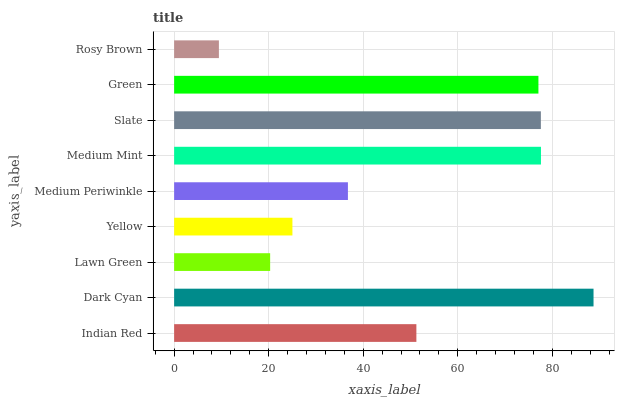Is Rosy Brown the minimum?
Answer yes or no. Yes. Is Dark Cyan the maximum?
Answer yes or no. Yes. Is Lawn Green the minimum?
Answer yes or no. No. Is Lawn Green the maximum?
Answer yes or no. No. Is Dark Cyan greater than Lawn Green?
Answer yes or no. Yes. Is Lawn Green less than Dark Cyan?
Answer yes or no. Yes. Is Lawn Green greater than Dark Cyan?
Answer yes or no. No. Is Dark Cyan less than Lawn Green?
Answer yes or no. No. Is Indian Red the high median?
Answer yes or no. Yes. Is Indian Red the low median?
Answer yes or no. Yes. Is Slate the high median?
Answer yes or no. No. Is Yellow the low median?
Answer yes or no. No. 